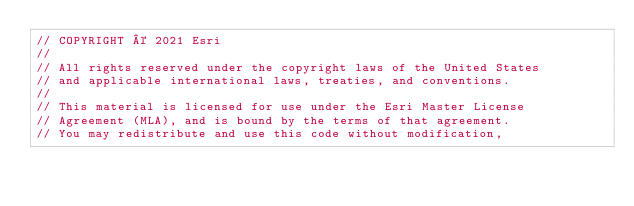Convert code to text. <code><loc_0><loc_0><loc_500><loc_500><_JavaScript_>// COPYRIGHT © 2021 Esri
//
// All rights reserved under the copyright laws of the United States
// and applicable international laws, treaties, and conventions.
//
// This material is licensed for use under the Esri Master License
// Agreement (MLA), and is bound by the terms of that agreement.
// You may redistribute and use this code without modification,</code> 